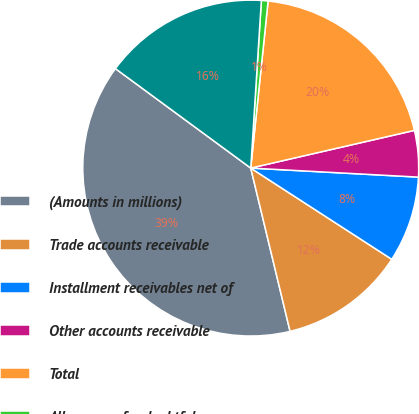Convert chart. <chart><loc_0><loc_0><loc_500><loc_500><pie_chart><fcel>(Amounts in millions)<fcel>Trade accounts receivable<fcel>Installment receivables net of<fcel>Other accounts receivable<fcel>Total<fcel>Allowances for doubtful<fcel>Total accounts receivable -<nl><fcel>38.85%<fcel>12.1%<fcel>8.28%<fcel>4.46%<fcel>19.75%<fcel>0.64%<fcel>15.92%<nl></chart> 